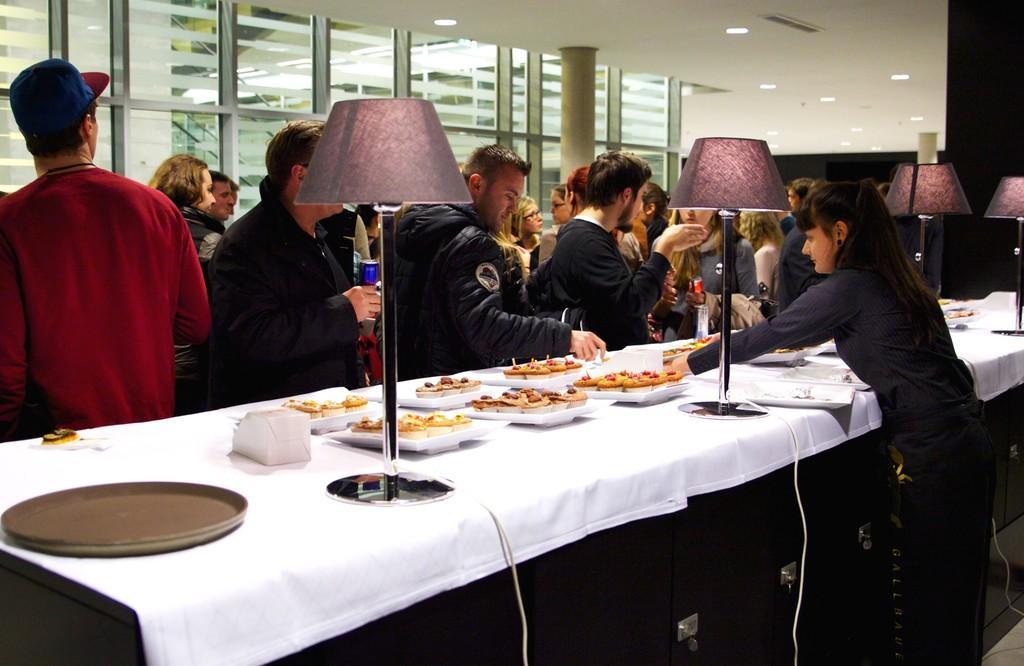Describe this image in one or two sentences. Here we can see a group of people standing in front of a table having plates of food on it and a women is serving the food and there are lamps placed on the table 